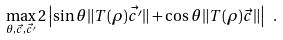Convert formula to latex. <formula><loc_0><loc_0><loc_500><loc_500>\max _ { \theta , \vec { c } , \vec { c ^ { \prime } } } 2 \left | \sin \theta \| T ( \rho ) \vec { c ^ { \prime } } \| + \cos \theta \| T ( \rho ) \vec { c } \| \right | \ .</formula> 